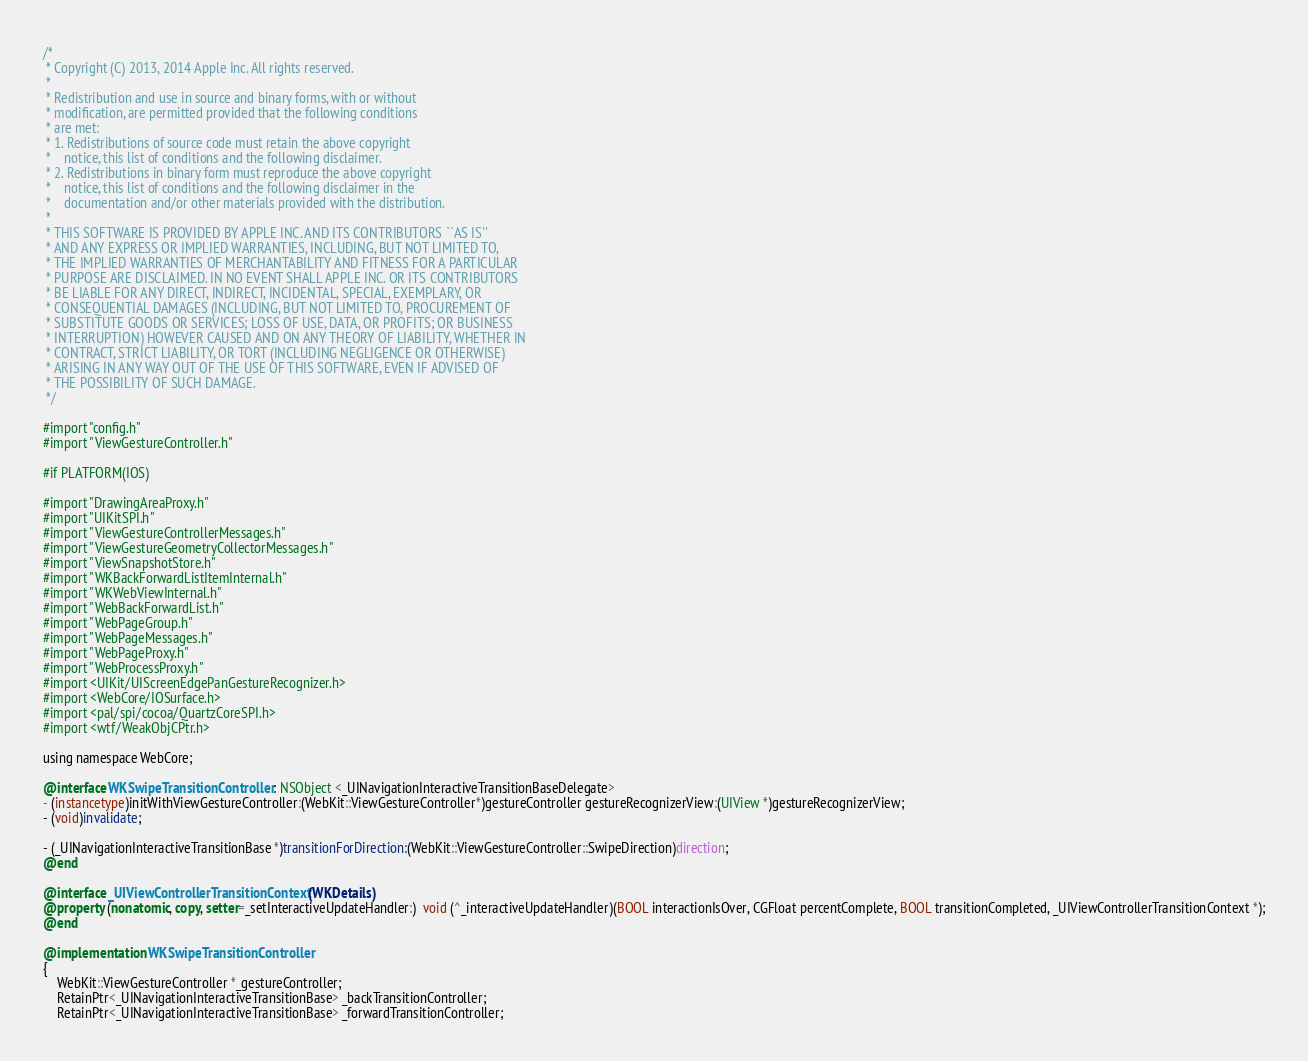Convert code to text. <code><loc_0><loc_0><loc_500><loc_500><_ObjectiveC_>/*
 * Copyright (C) 2013, 2014 Apple Inc. All rights reserved.
 *
 * Redistribution and use in source and binary forms, with or without
 * modification, are permitted provided that the following conditions
 * are met:
 * 1. Redistributions of source code must retain the above copyright
 *    notice, this list of conditions and the following disclaimer.
 * 2. Redistributions in binary form must reproduce the above copyright
 *    notice, this list of conditions and the following disclaimer in the
 *    documentation and/or other materials provided with the distribution.
 *
 * THIS SOFTWARE IS PROVIDED BY APPLE INC. AND ITS CONTRIBUTORS ``AS IS''
 * AND ANY EXPRESS OR IMPLIED WARRANTIES, INCLUDING, BUT NOT LIMITED TO,
 * THE IMPLIED WARRANTIES OF MERCHANTABILITY AND FITNESS FOR A PARTICULAR
 * PURPOSE ARE DISCLAIMED. IN NO EVENT SHALL APPLE INC. OR ITS CONTRIBUTORS
 * BE LIABLE FOR ANY DIRECT, INDIRECT, INCIDENTAL, SPECIAL, EXEMPLARY, OR
 * CONSEQUENTIAL DAMAGES (INCLUDING, BUT NOT LIMITED TO, PROCUREMENT OF
 * SUBSTITUTE GOODS OR SERVICES; LOSS OF USE, DATA, OR PROFITS; OR BUSINESS
 * INTERRUPTION) HOWEVER CAUSED AND ON ANY THEORY OF LIABILITY, WHETHER IN
 * CONTRACT, STRICT LIABILITY, OR TORT (INCLUDING NEGLIGENCE OR OTHERWISE)
 * ARISING IN ANY WAY OUT OF THE USE OF THIS SOFTWARE, EVEN IF ADVISED OF
 * THE POSSIBILITY OF SUCH DAMAGE.
 */

#import "config.h"
#import "ViewGestureController.h"

#if PLATFORM(IOS)

#import "DrawingAreaProxy.h"
#import "UIKitSPI.h"
#import "ViewGestureControllerMessages.h"
#import "ViewGestureGeometryCollectorMessages.h"
#import "ViewSnapshotStore.h"
#import "WKBackForwardListItemInternal.h"
#import "WKWebViewInternal.h"
#import "WebBackForwardList.h"
#import "WebPageGroup.h"
#import "WebPageMessages.h"
#import "WebPageProxy.h"
#import "WebProcessProxy.h"
#import <UIKit/UIScreenEdgePanGestureRecognizer.h>
#import <WebCore/IOSurface.h>
#import <pal/spi/cocoa/QuartzCoreSPI.h>
#import <wtf/WeakObjCPtr.h>

using namespace WebCore;

@interface WKSwipeTransitionController : NSObject <_UINavigationInteractiveTransitionBaseDelegate>
- (instancetype)initWithViewGestureController:(WebKit::ViewGestureController*)gestureController gestureRecognizerView:(UIView *)gestureRecognizerView;
- (void)invalidate;

- (_UINavigationInteractiveTransitionBase *)transitionForDirection:(WebKit::ViewGestureController::SwipeDirection)direction;
@end

@interface _UIViewControllerTransitionContext (WKDetails)
@property (nonatomic, copy, setter=_setInteractiveUpdateHandler:)  void (^_interactiveUpdateHandler)(BOOL interactionIsOver, CGFloat percentComplete, BOOL transitionCompleted, _UIViewControllerTransitionContext *);
@end

@implementation WKSwipeTransitionController
{
    WebKit::ViewGestureController *_gestureController;
    RetainPtr<_UINavigationInteractiveTransitionBase> _backTransitionController;
    RetainPtr<_UINavigationInteractiveTransitionBase> _forwardTransitionController;</code> 